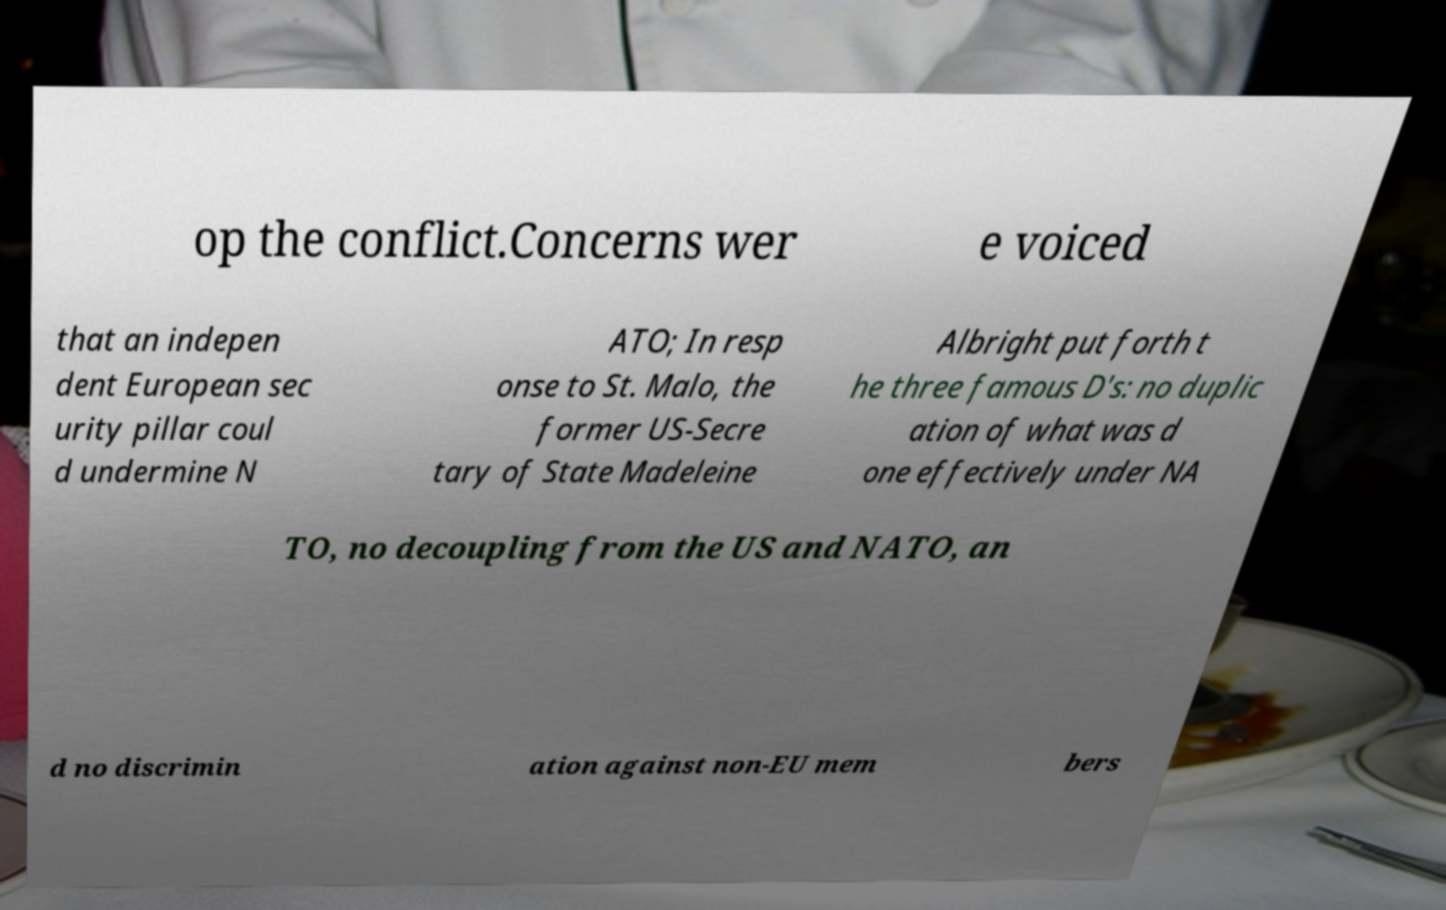What messages or text are displayed in this image? I need them in a readable, typed format. op the conflict.Concerns wer e voiced that an indepen dent European sec urity pillar coul d undermine N ATO; In resp onse to St. Malo, the former US-Secre tary of State Madeleine Albright put forth t he three famous D's: no duplic ation of what was d one effectively under NA TO, no decoupling from the US and NATO, an d no discrimin ation against non-EU mem bers 